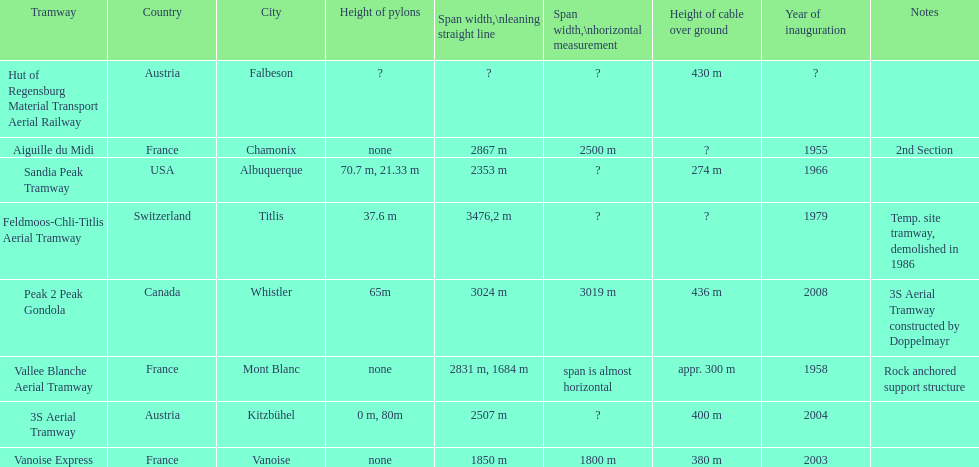Which tramway was inaugurated first, the 3s aerial tramway or the aiguille du midi? Aiguille du Midi. 